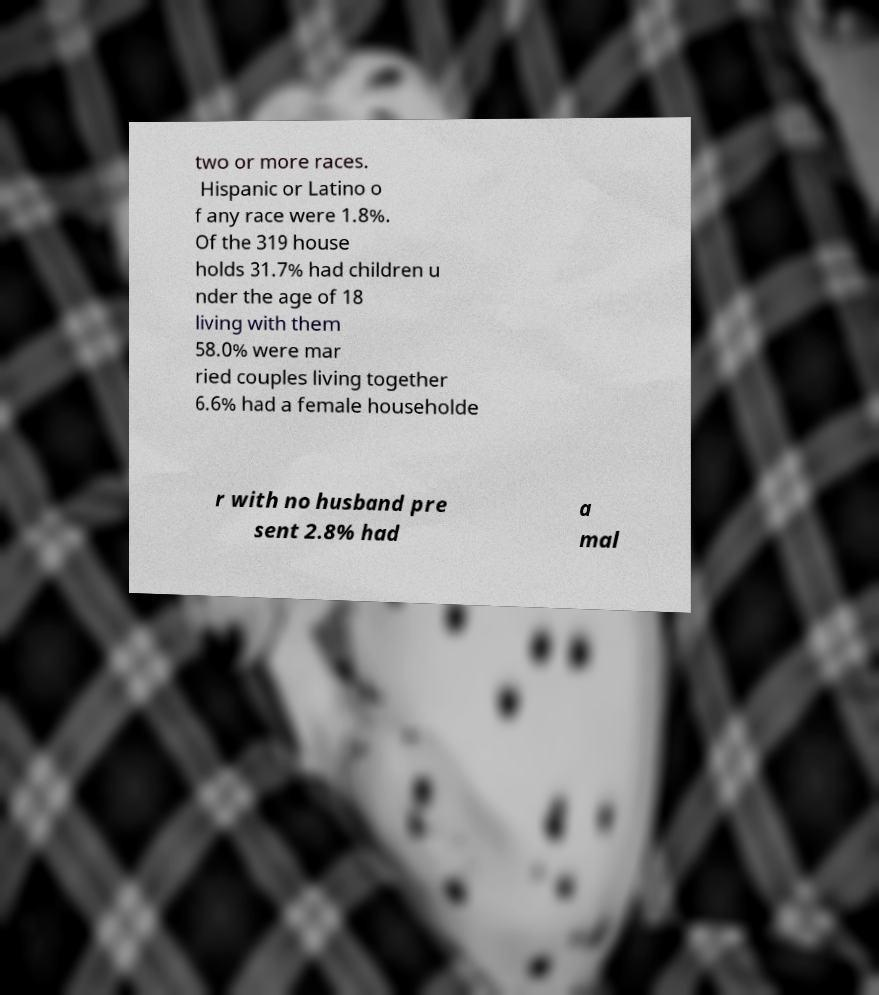Please identify and transcribe the text found in this image. two or more races. Hispanic or Latino o f any race were 1.8%. Of the 319 house holds 31.7% had children u nder the age of 18 living with them 58.0% were mar ried couples living together 6.6% had a female householde r with no husband pre sent 2.8% had a mal 